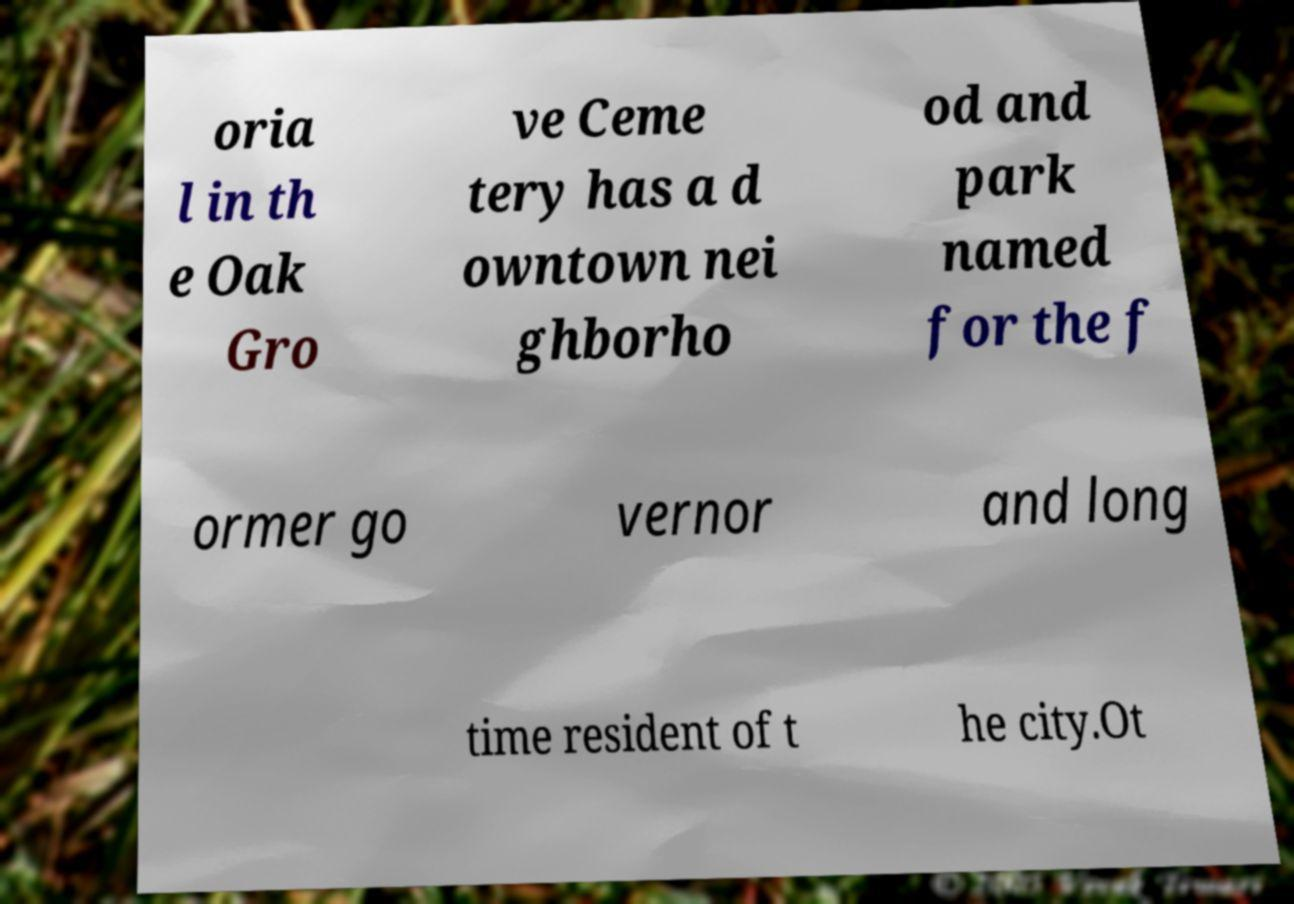Please identify and transcribe the text found in this image. oria l in th e Oak Gro ve Ceme tery has a d owntown nei ghborho od and park named for the f ormer go vernor and long time resident of t he city.Ot 